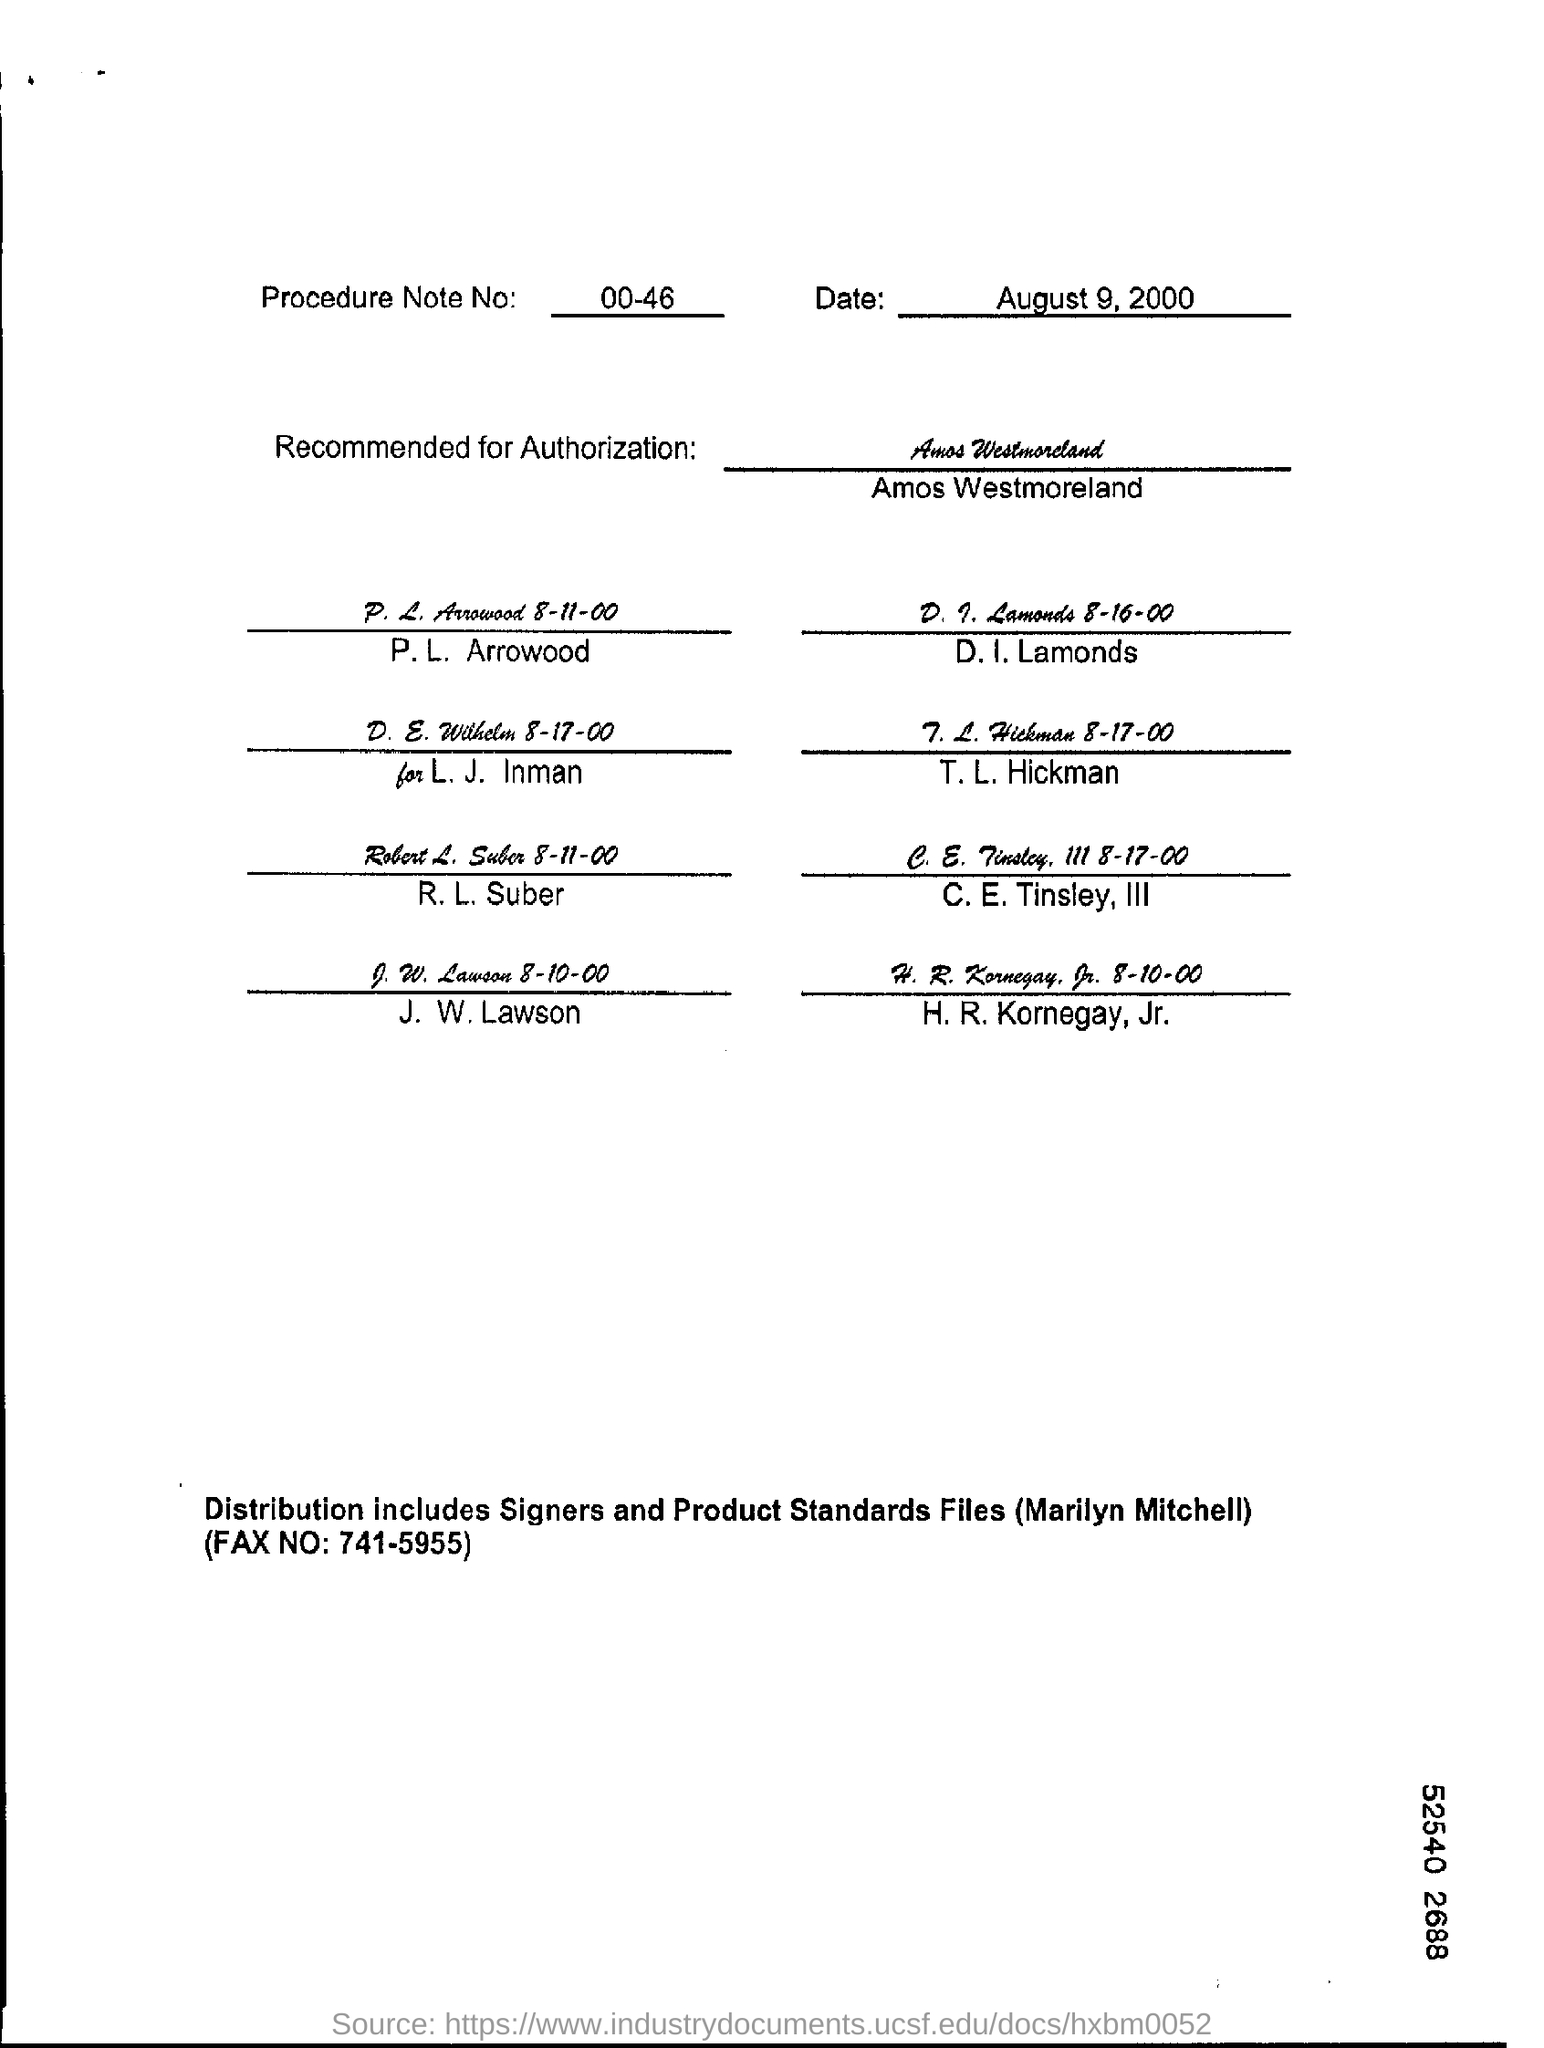Point out several critical features in this image. The form is dated August 9, 2000. The procedure note number is 00-46. 